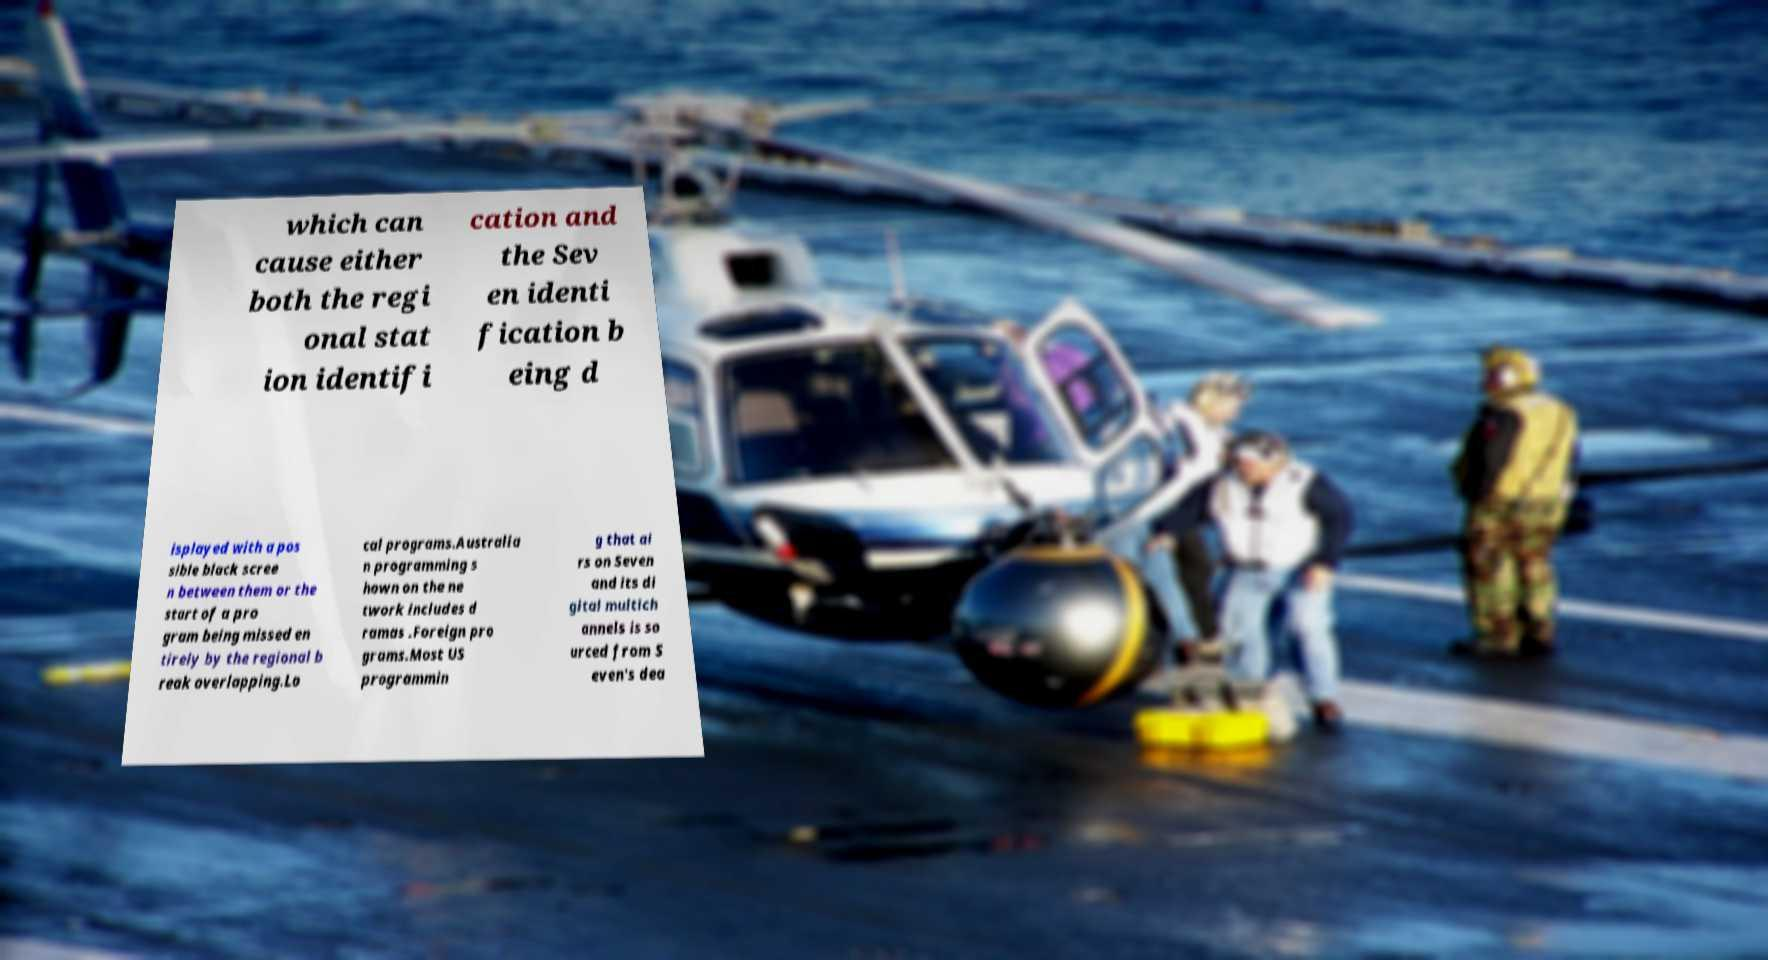Could you extract and type out the text from this image? which can cause either both the regi onal stat ion identifi cation and the Sev en identi fication b eing d isplayed with a pos sible black scree n between them or the start of a pro gram being missed en tirely by the regional b reak overlapping.Lo cal programs.Australia n programming s hown on the ne twork includes d ramas .Foreign pro grams.Most US programmin g that ai rs on Seven and its di gital multich annels is so urced from S even's dea 